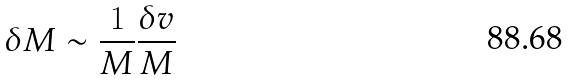Convert formula to latex. <formula><loc_0><loc_0><loc_500><loc_500>\delta M \sim \frac { 1 } { M } \frac { \delta v } { M }</formula> 